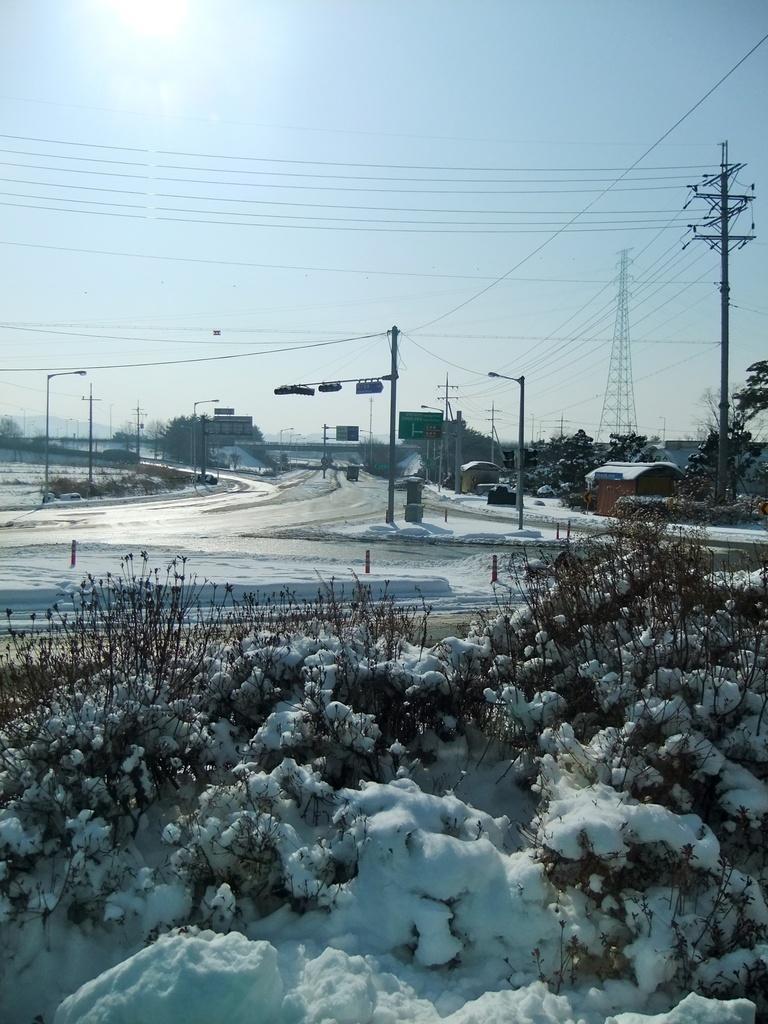Please provide a concise description of this image. In this picture in the front there are plants and on the plants there is snow. In the background there are trees, poles and there are wires and there is a tower and there is a house. 